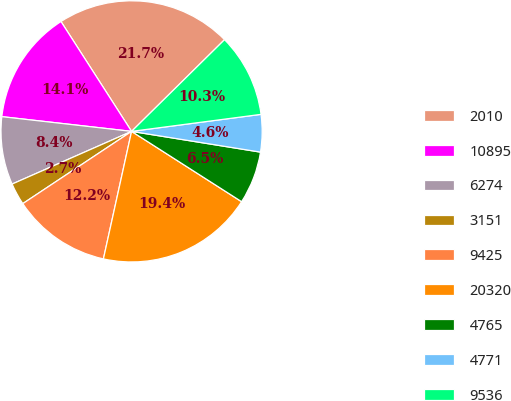<chart> <loc_0><loc_0><loc_500><loc_500><pie_chart><fcel>2010<fcel>10895<fcel>6274<fcel>3151<fcel>9425<fcel>20320<fcel>4765<fcel>4771<fcel>9536<nl><fcel>21.7%<fcel>14.11%<fcel>8.41%<fcel>2.72%<fcel>12.21%<fcel>19.41%<fcel>6.51%<fcel>4.62%<fcel>10.31%<nl></chart> 